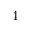<formula> <loc_0><loc_0><loc_500><loc_500>4</formula> 